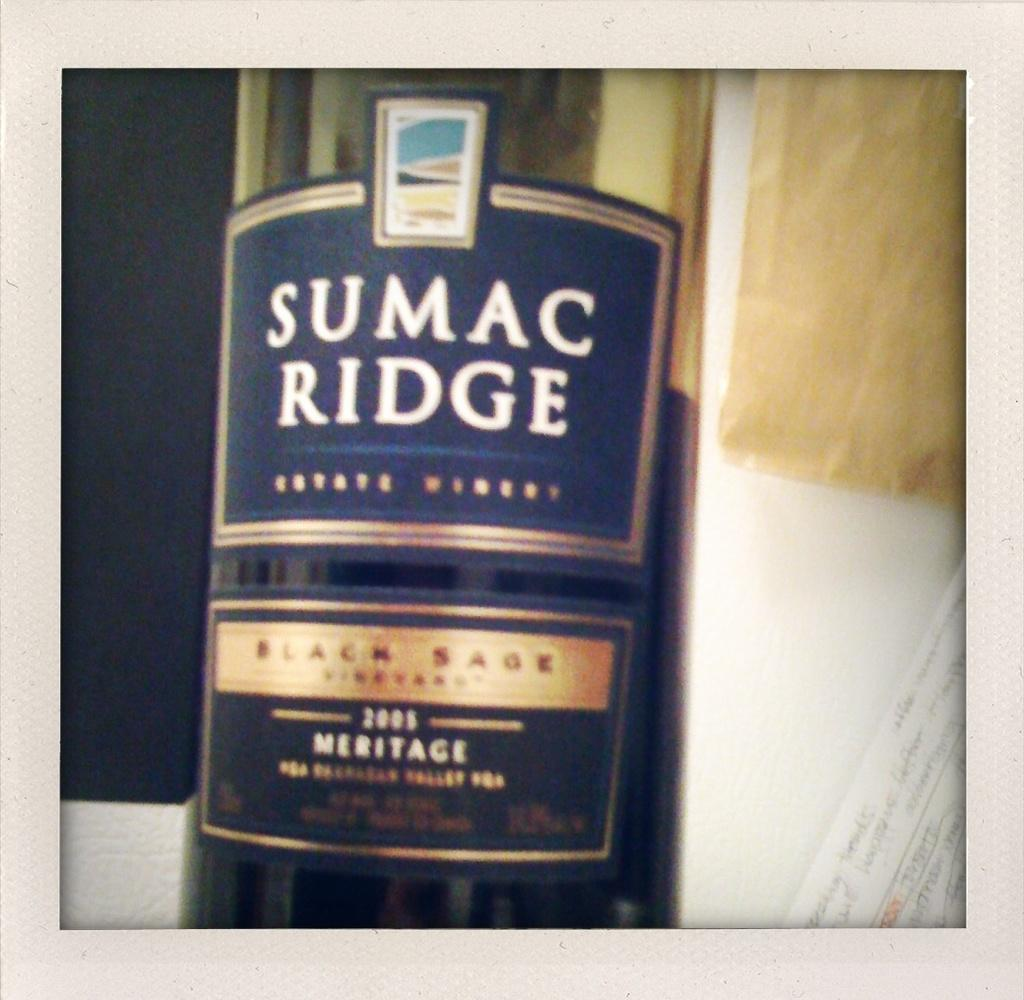<image>
Create a compact narrative representing the image presented. a bottle that says sumac ridge on it 